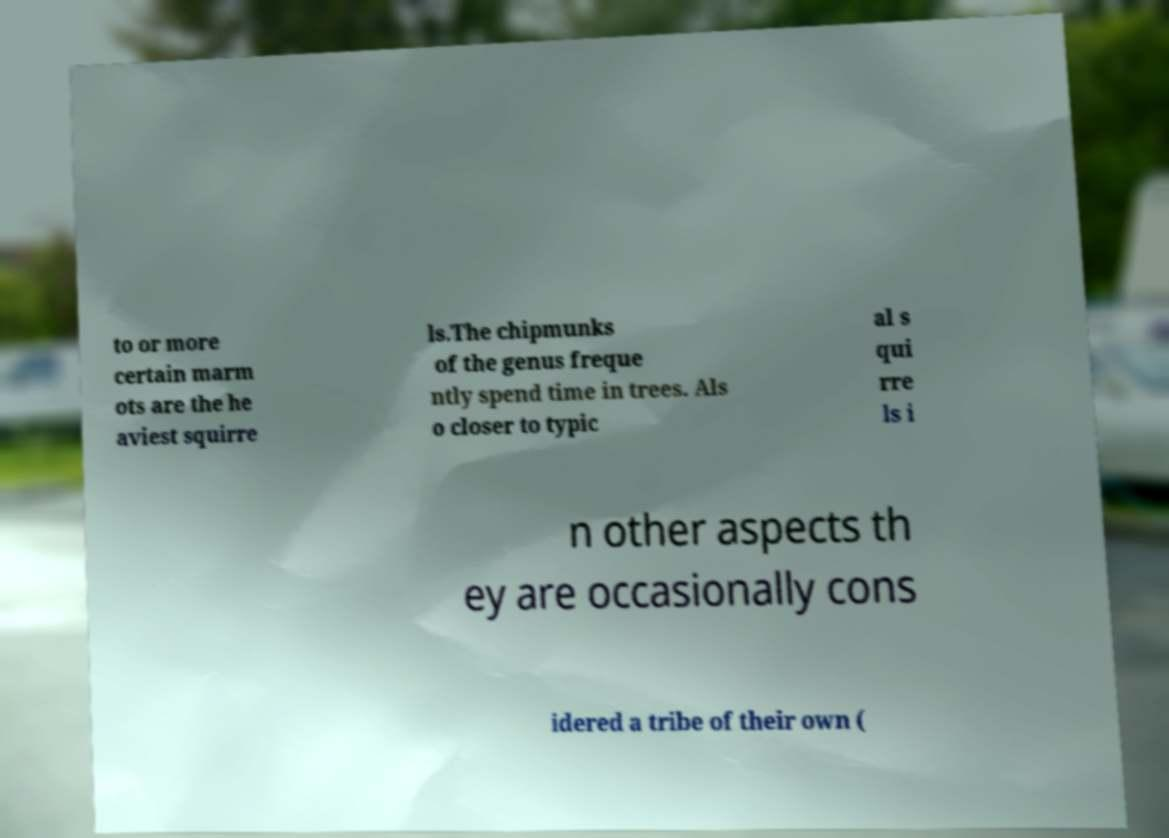What messages or text are displayed in this image? I need them in a readable, typed format. to or more certain marm ots are the he aviest squirre ls.The chipmunks of the genus freque ntly spend time in trees. Als o closer to typic al s qui rre ls i n other aspects th ey are occasionally cons idered a tribe of their own ( 